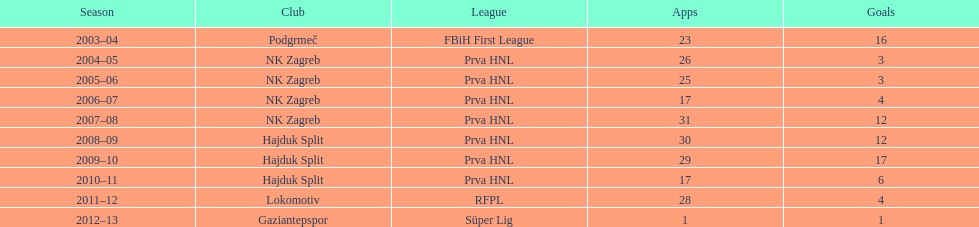Did ibricic have a greater or lesser goal tally in his 3 seasons at hajduk split compared to his 4 seasons at nk zagreb? More. 